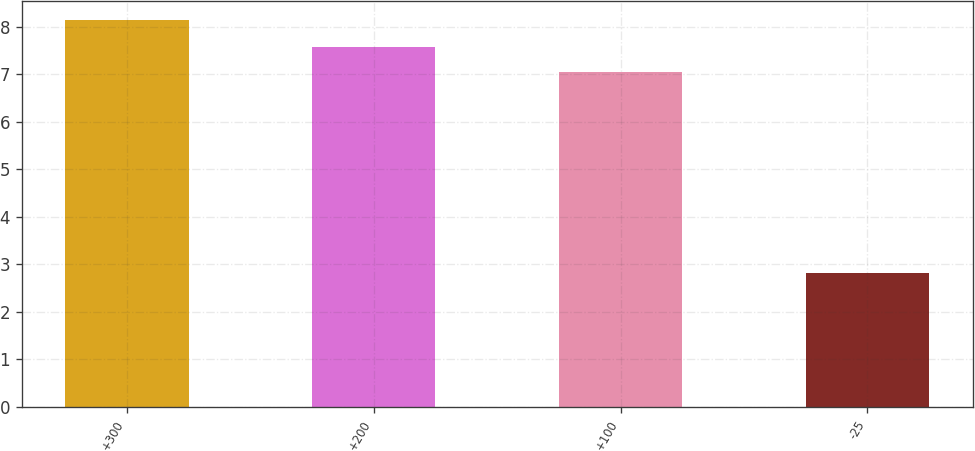Convert chart. <chart><loc_0><loc_0><loc_500><loc_500><bar_chart><fcel>+300<fcel>+200<fcel>+100<fcel>-25<nl><fcel>8.14<fcel>7.57<fcel>7.04<fcel>2.81<nl></chart> 